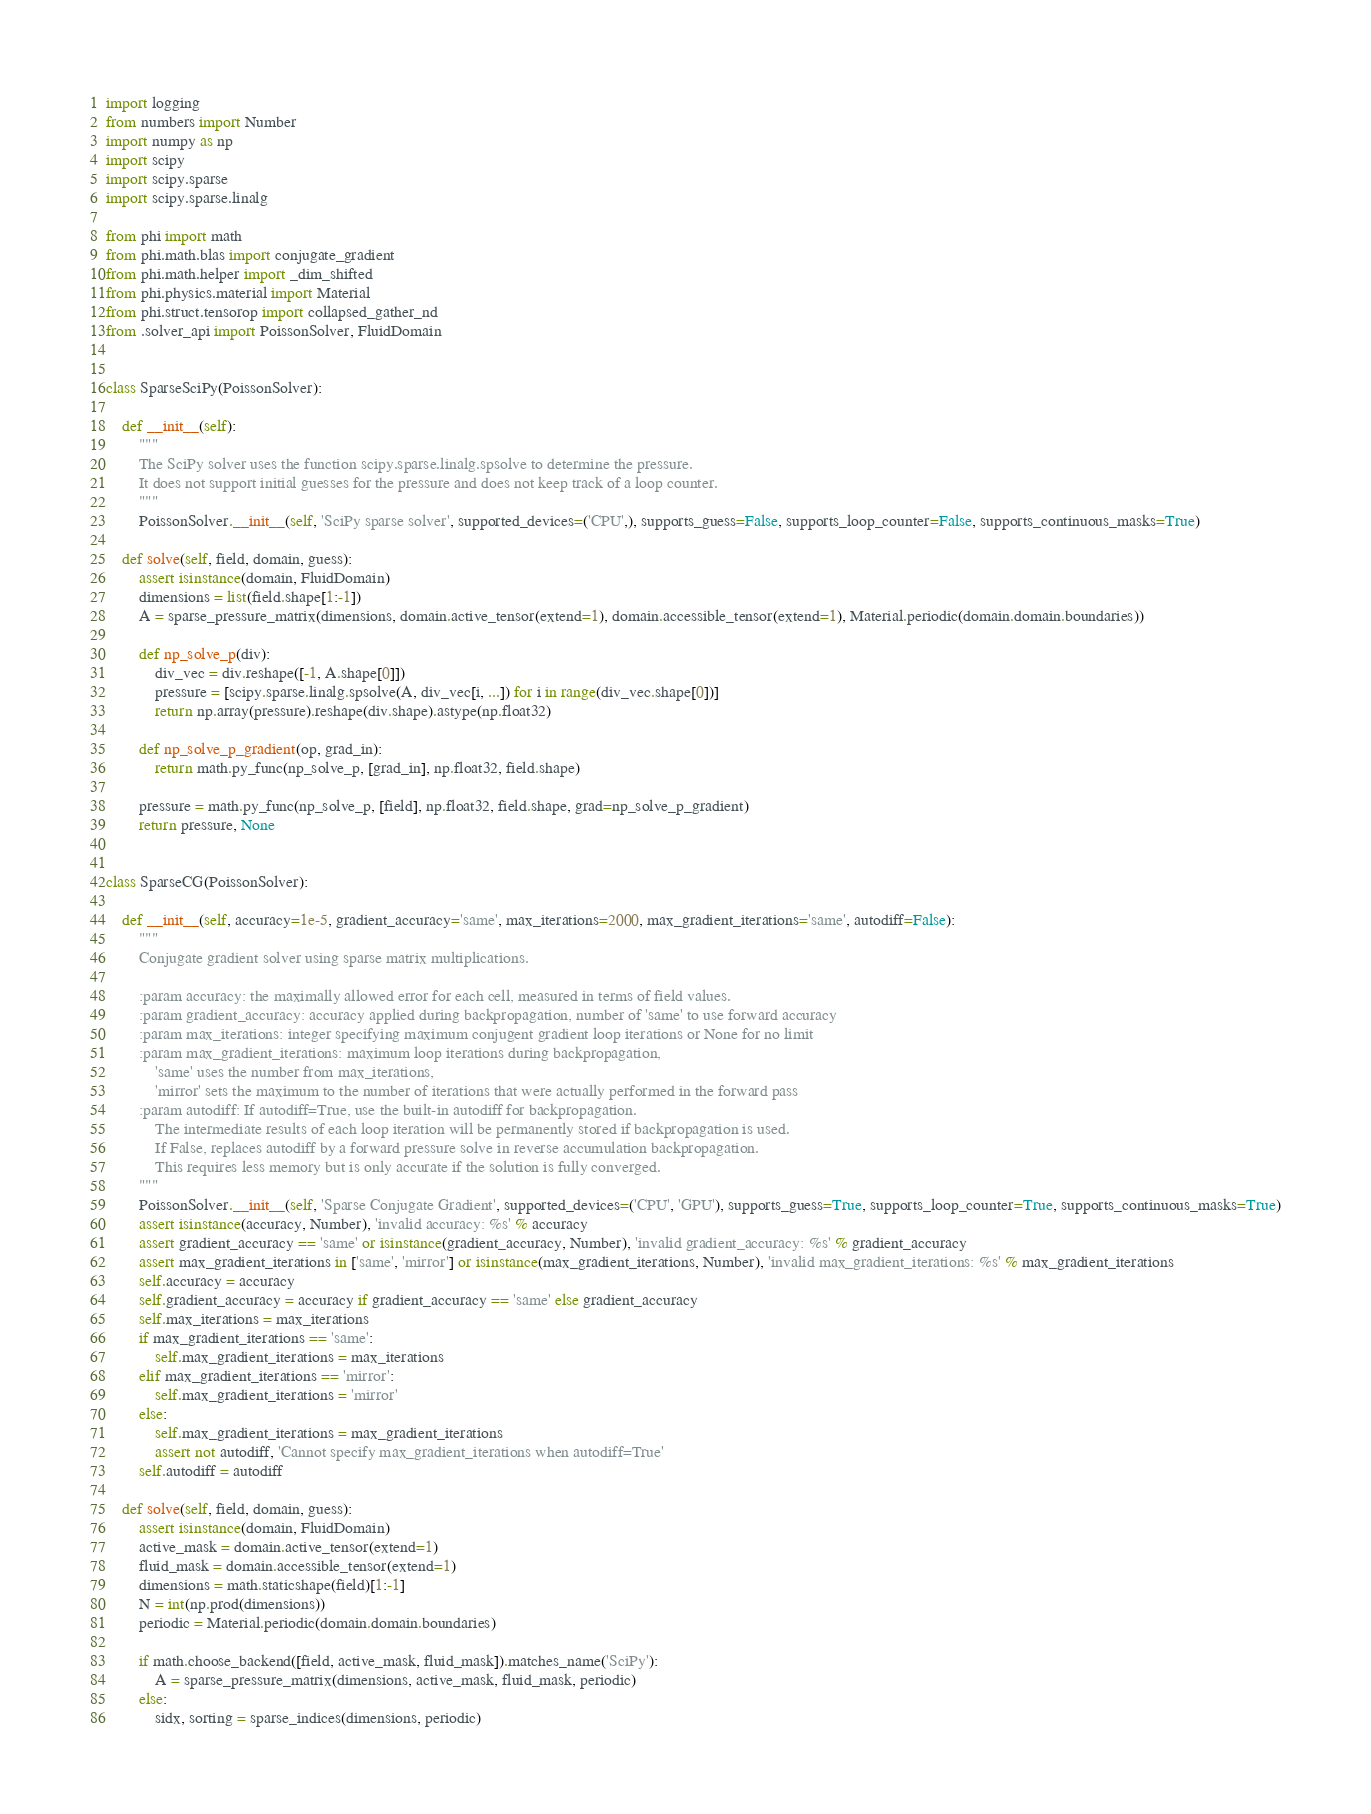Convert code to text. <code><loc_0><loc_0><loc_500><loc_500><_Python_>import logging
from numbers import Number
import numpy as np
import scipy
import scipy.sparse
import scipy.sparse.linalg

from phi import math
from phi.math.blas import conjugate_gradient
from phi.math.helper import _dim_shifted
from phi.physics.material import Material
from phi.struct.tensorop import collapsed_gather_nd
from .solver_api import PoissonSolver, FluidDomain


class SparseSciPy(PoissonSolver):

    def __init__(self):
        """
        The SciPy solver uses the function scipy.sparse.linalg.spsolve to determine the pressure.
        It does not support initial guesses for the pressure and does not keep track of a loop counter.
        """
        PoissonSolver.__init__(self, 'SciPy sparse solver', supported_devices=('CPU',), supports_guess=False, supports_loop_counter=False, supports_continuous_masks=True)

    def solve(self, field, domain, guess):
        assert isinstance(domain, FluidDomain)
        dimensions = list(field.shape[1:-1])
        A = sparse_pressure_matrix(dimensions, domain.active_tensor(extend=1), domain.accessible_tensor(extend=1), Material.periodic(domain.domain.boundaries))

        def np_solve_p(div):
            div_vec = div.reshape([-1, A.shape[0]])
            pressure = [scipy.sparse.linalg.spsolve(A, div_vec[i, ...]) for i in range(div_vec.shape[0])]
            return np.array(pressure).reshape(div.shape).astype(np.float32)

        def np_solve_p_gradient(op, grad_in):
            return math.py_func(np_solve_p, [grad_in], np.float32, field.shape)

        pressure = math.py_func(np_solve_p, [field], np.float32, field.shape, grad=np_solve_p_gradient)
        return pressure, None


class SparseCG(PoissonSolver):

    def __init__(self, accuracy=1e-5, gradient_accuracy='same', max_iterations=2000, max_gradient_iterations='same', autodiff=False):
        """
        Conjugate gradient solver using sparse matrix multiplications.

        :param accuracy: the maximally allowed error for each cell, measured in terms of field values.
        :param gradient_accuracy: accuracy applied during backpropagation, number of 'same' to use forward accuracy
        :param max_iterations: integer specifying maximum conjugent gradient loop iterations or None for no limit
        :param max_gradient_iterations: maximum loop iterations during backpropagation,
            'same' uses the number from max_iterations,
            'mirror' sets the maximum to the number of iterations that were actually performed in the forward pass
        :param autodiff: If autodiff=True, use the built-in autodiff for backpropagation.
            The intermediate results of each loop iteration will be permanently stored if backpropagation is used.
            If False, replaces autodiff by a forward pressure solve in reverse accumulation backpropagation.
            This requires less memory but is only accurate if the solution is fully converged.
        """
        PoissonSolver.__init__(self, 'Sparse Conjugate Gradient', supported_devices=('CPU', 'GPU'), supports_guess=True, supports_loop_counter=True, supports_continuous_masks=True)
        assert isinstance(accuracy, Number), 'invalid accuracy: %s' % accuracy
        assert gradient_accuracy == 'same' or isinstance(gradient_accuracy, Number), 'invalid gradient_accuracy: %s' % gradient_accuracy
        assert max_gradient_iterations in ['same', 'mirror'] or isinstance(max_gradient_iterations, Number), 'invalid max_gradient_iterations: %s' % max_gradient_iterations
        self.accuracy = accuracy
        self.gradient_accuracy = accuracy if gradient_accuracy == 'same' else gradient_accuracy
        self.max_iterations = max_iterations
        if max_gradient_iterations == 'same':
            self.max_gradient_iterations = max_iterations
        elif max_gradient_iterations == 'mirror':
            self.max_gradient_iterations = 'mirror'
        else:
            self.max_gradient_iterations = max_gradient_iterations
            assert not autodiff, 'Cannot specify max_gradient_iterations when autodiff=True'
        self.autodiff = autodiff

    def solve(self, field, domain, guess):
        assert isinstance(domain, FluidDomain)
        active_mask = domain.active_tensor(extend=1)
        fluid_mask = domain.accessible_tensor(extend=1)
        dimensions = math.staticshape(field)[1:-1]
        N = int(np.prod(dimensions))
        periodic = Material.periodic(domain.domain.boundaries)

        if math.choose_backend([field, active_mask, fluid_mask]).matches_name('SciPy'):
            A = sparse_pressure_matrix(dimensions, active_mask, fluid_mask, periodic)
        else:
            sidx, sorting = sparse_indices(dimensions, periodic)</code> 